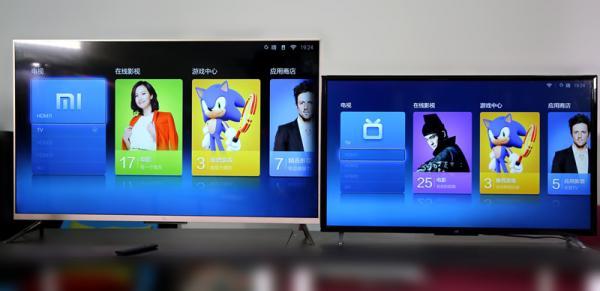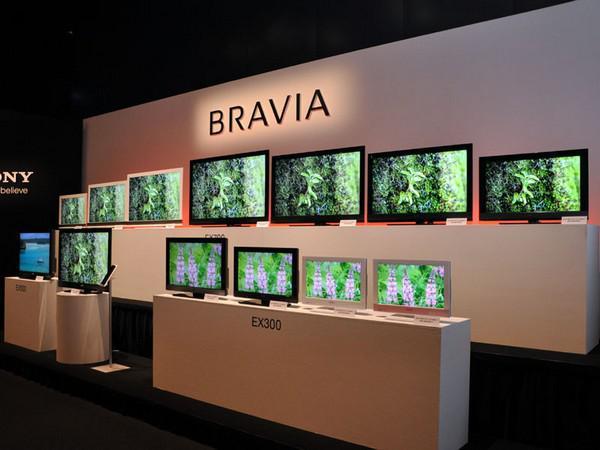The first image is the image on the left, the second image is the image on the right. Given the left and right images, does the statement "The right image contains more operating screens than the left image." hold true? Answer yes or no. Yes. The first image is the image on the left, the second image is the image on the right. For the images displayed, is the sentence "There are three monitors increasing in size with identical video being broadcast." factually correct? Answer yes or no. No. 